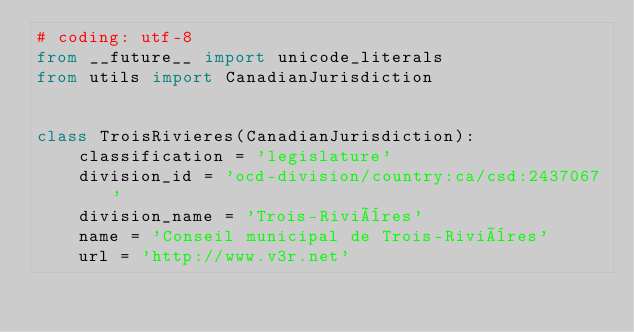<code> <loc_0><loc_0><loc_500><loc_500><_Python_># coding: utf-8
from __future__ import unicode_literals
from utils import CanadianJurisdiction


class TroisRivieres(CanadianJurisdiction):
    classification = 'legislature'
    division_id = 'ocd-division/country:ca/csd:2437067'
    division_name = 'Trois-Rivières'
    name = 'Conseil municipal de Trois-Rivières'
    url = 'http://www.v3r.net'
</code> 